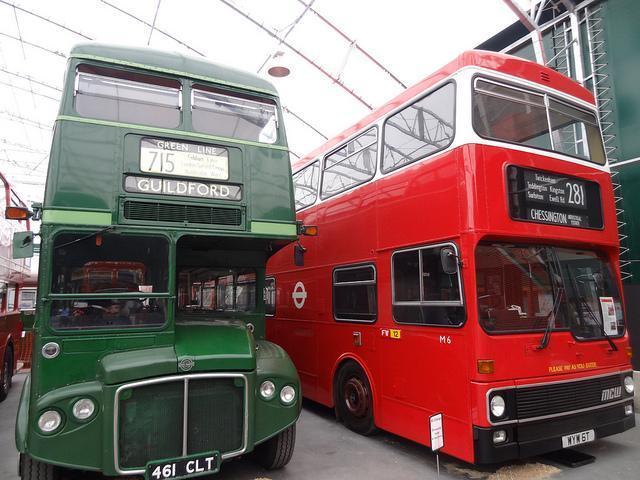How many buses are in the picture?
Give a very brief answer. 2. How many buses are parked side by side?
Give a very brief answer. 2. 